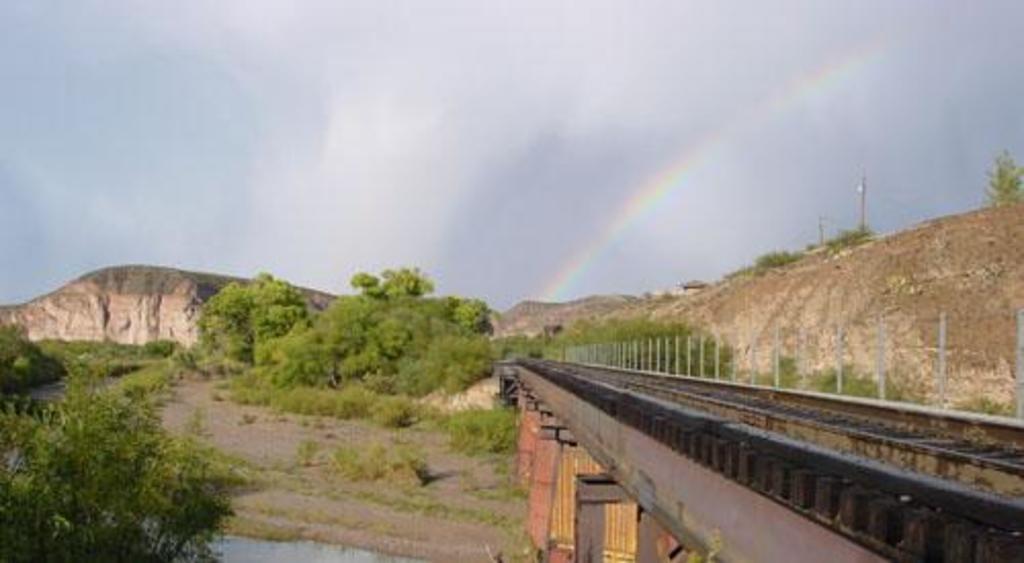Please provide a concise description of this image. In this image we can see few trees. There are many plants in the image. There is a bridge at the right side of the image. We can see the clouds in the sky. There are few hills in the image. We can see the water at the bottom of the image. 